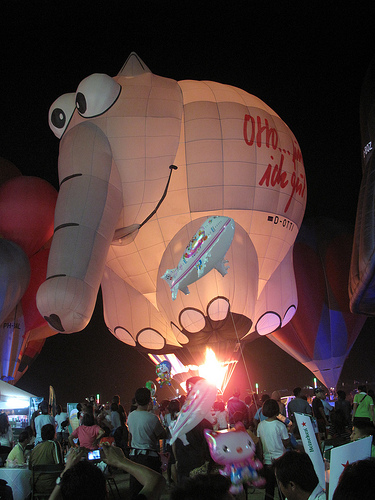<image>
Can you confirm if the ballon is above the person? Yes. The ballon is positioned above the person in the vertical space, higher up in the scene. 